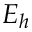Convert formula to latex. <formula><loc_0><loc_0><loc_500><loc_500>E _ { h }</formula> 